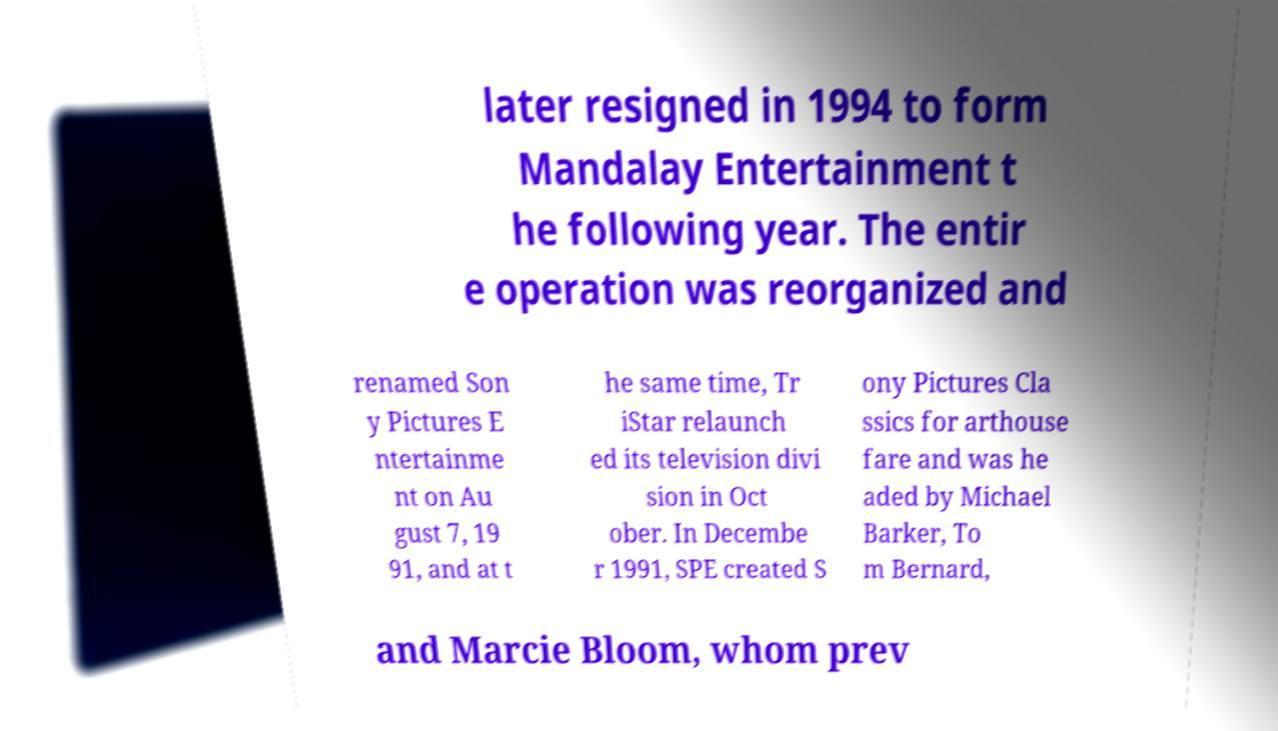Please identify and transcribe the text found in this image. later resigned in 1994 to form Mandalay Entertainment t he following year. The entir e operation was reorganized and renamed Son y Pictures E ntertainme nt on Au gust 7, 19 91, and at t he same time, Tr iStar relaunch ed its television divi sion in Oct ober. In Decembe r 1991, SPE created S ony Pictures Cla ssics for arthouse fare and was he aded by Michael Barker, To m Bernard, and Marcie Bloom, whom prev 